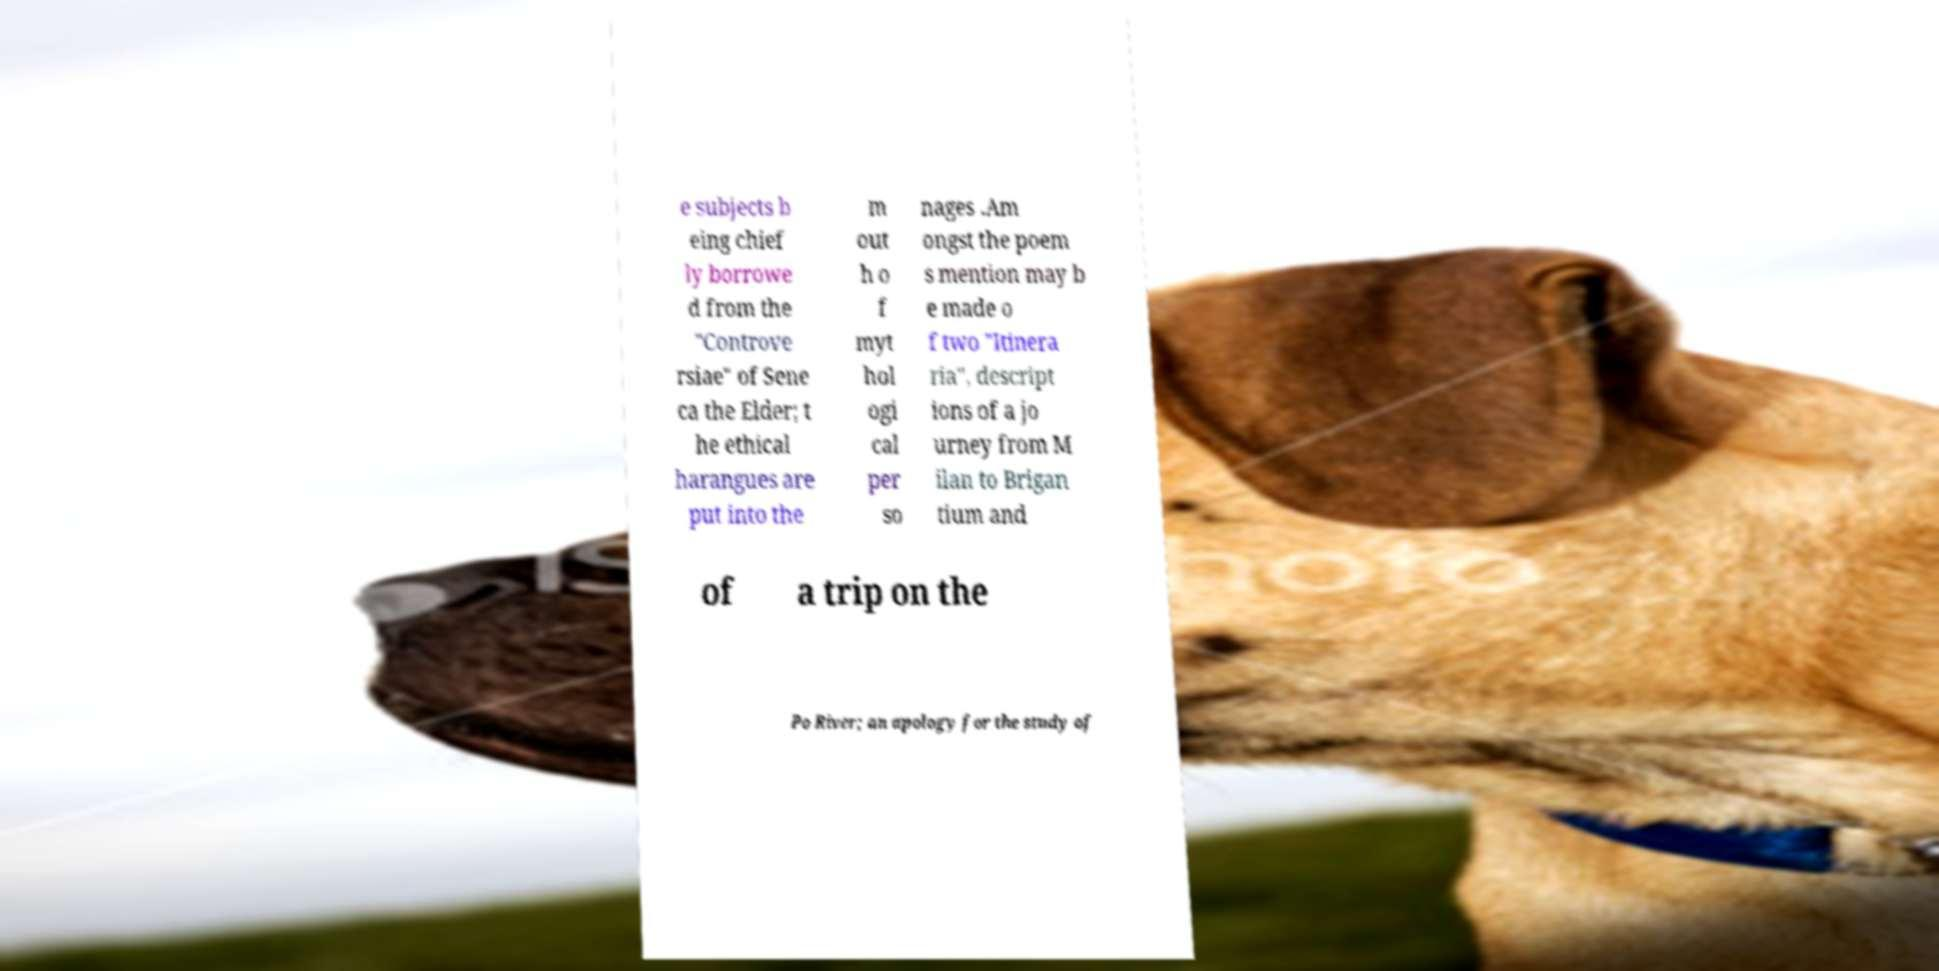I need the written content from this picture converted into text. Can you do that? e subjects b eing chief ly borrowe d from the "Controve rsiae" of Sene ca the Elder; t he ethical harangues are put into the m out h o f myt hol ogi cal per so nages .Am ongst the poem s mention may b e made o f two "Itinera ria", descript ions of a jo urney from M ilan to Brigan tium and of a trip on the Po River; an apology for the study of 